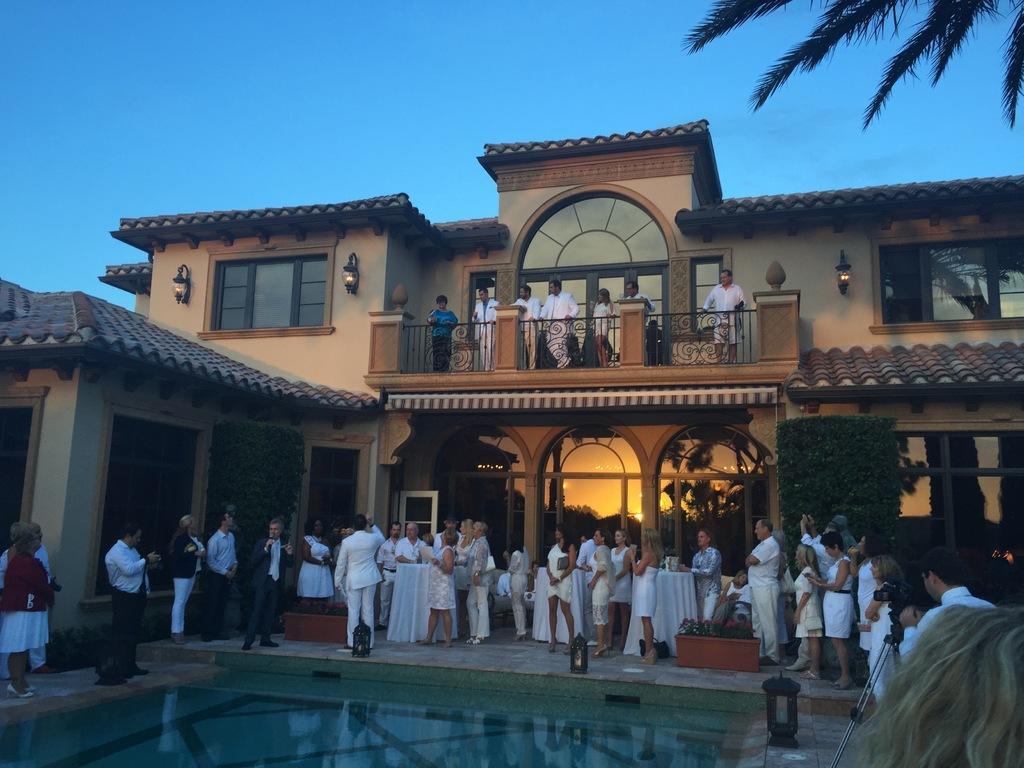Describe this image in one or two sentences. Bottom of the image there is water. In the middle of the image few people are standing and watching. Behind them there are some plants and building, on the building few people are standing and watching. Top of the image there is sky. 